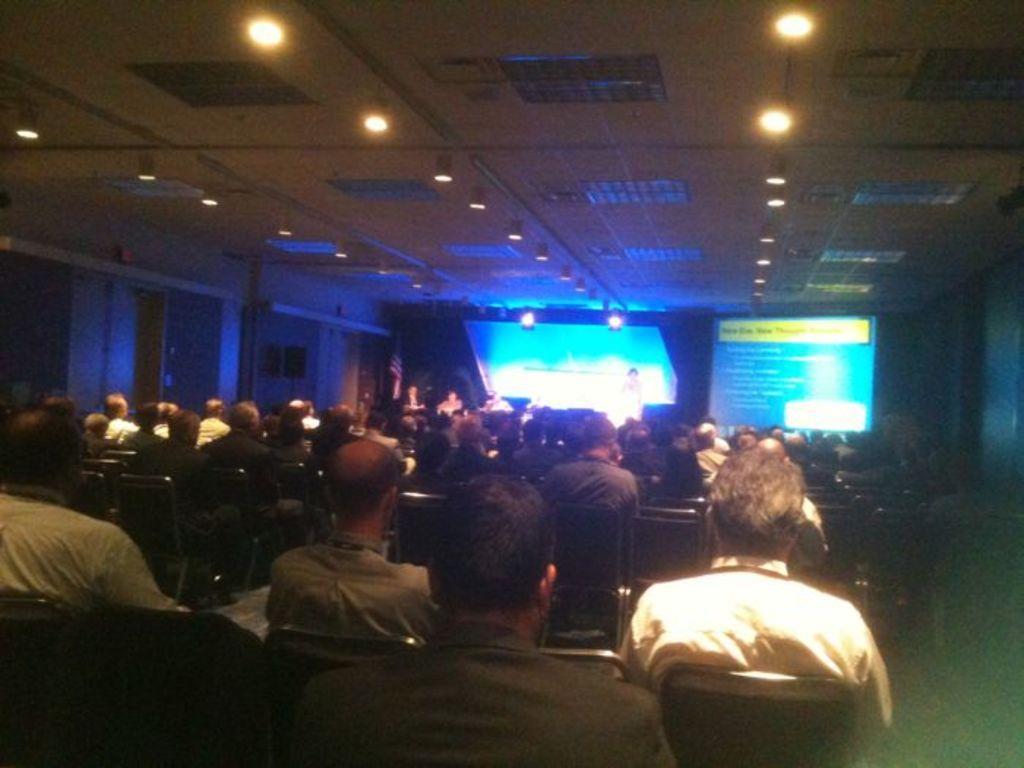Describe this image in one or two sentences. In this image I can see group of people sitting. Background I can see a projector screen and few lights. 